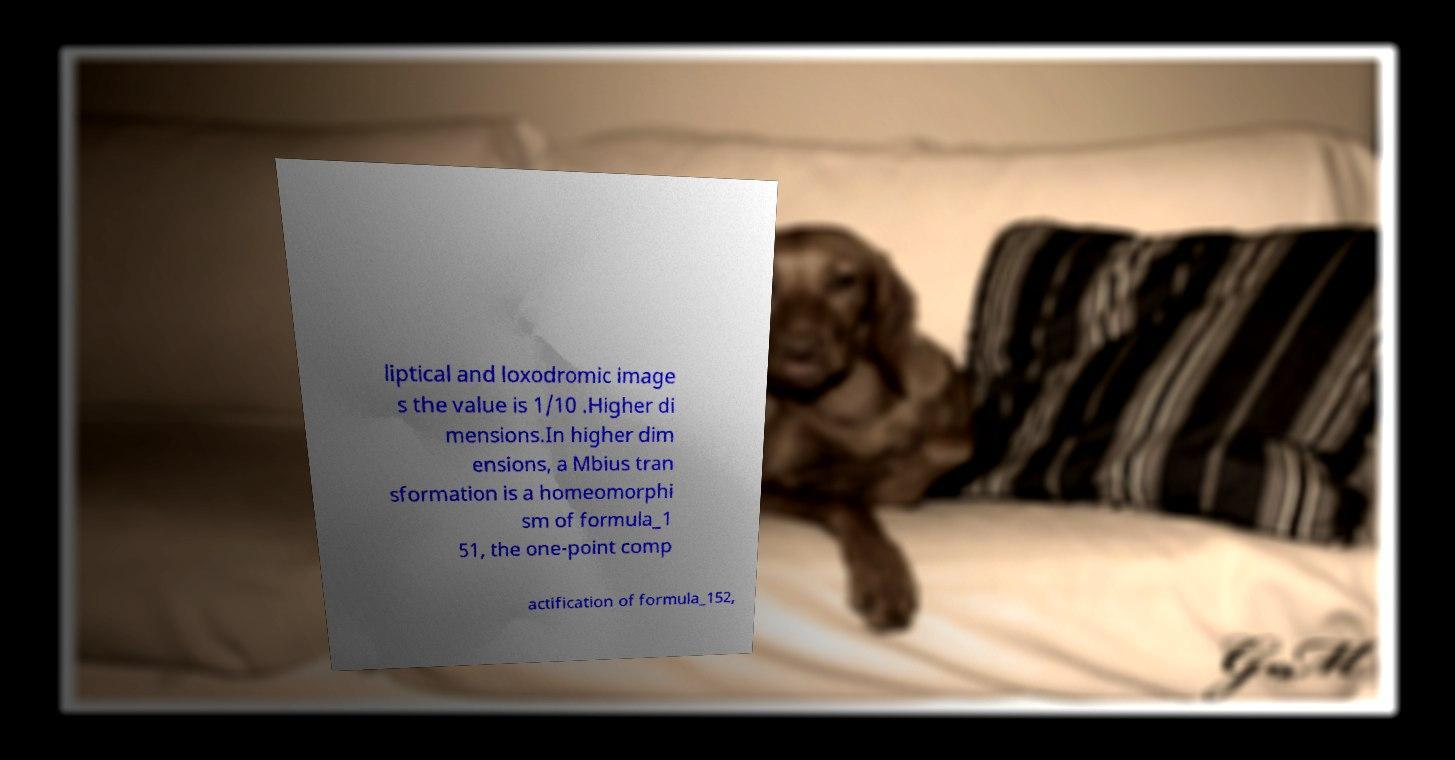Can you read and provide the text displayed in the image?This photo seems to have some interesting text. Can you extract and type it out for me? liptical and loxodromic image s the value is 1/10 .Higher di mensions.In higher dim ensions, a Mbius tran sformation is a homeomorphi sm of formula_1 51, the one-point comp actification of formula_152, 